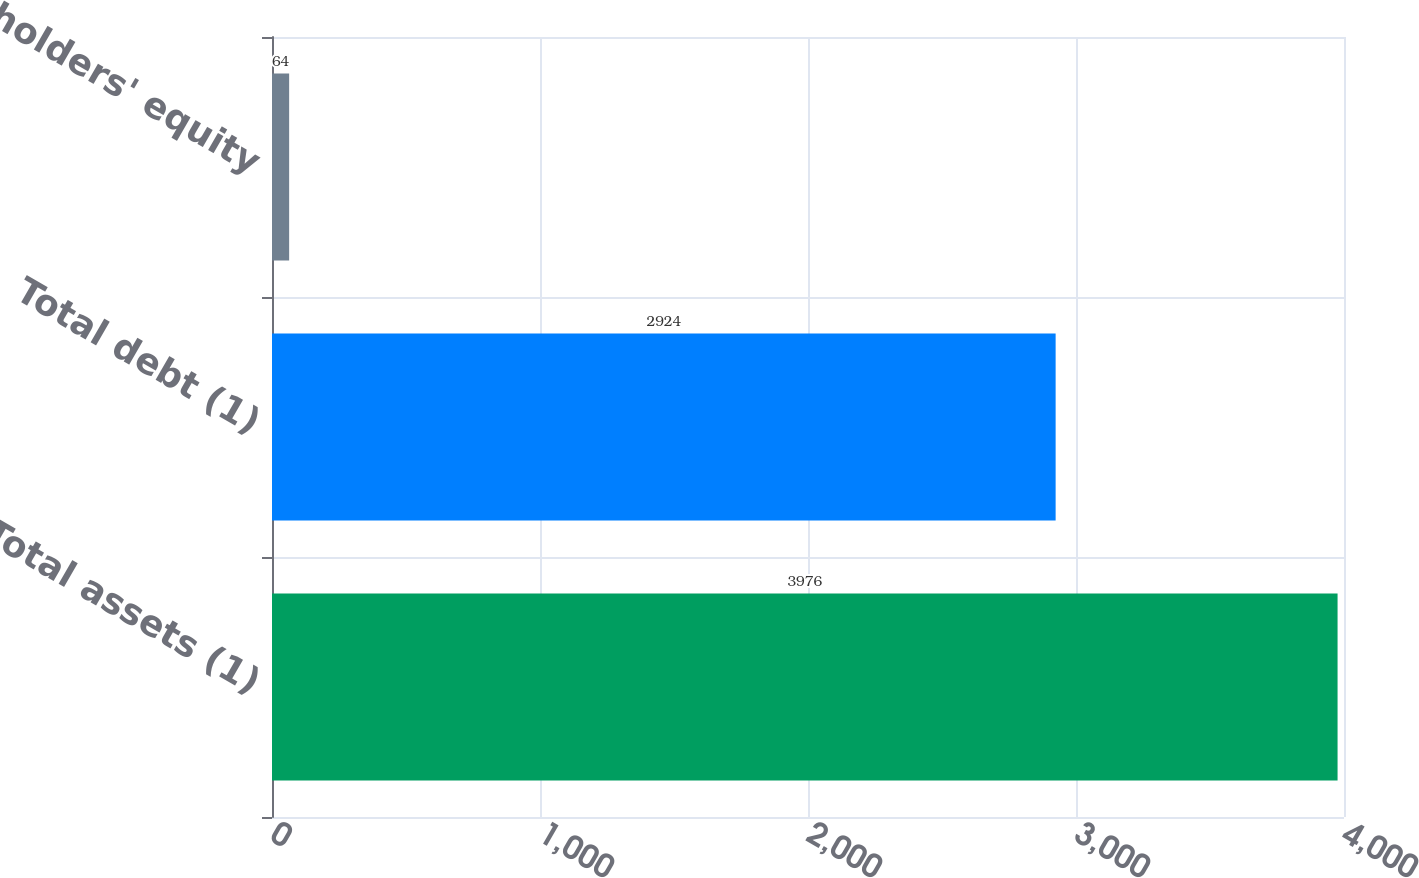Convert chart to OTSL. <chart><loc_0><loc_0><loc_500><loc_500><bar_chart><fcel>Total assets (1)<fcel>Total debt (1)<fcel>Stockholders' equity<nl><fcel>3976<fcel>2924<fcel>64<nl></chart> 